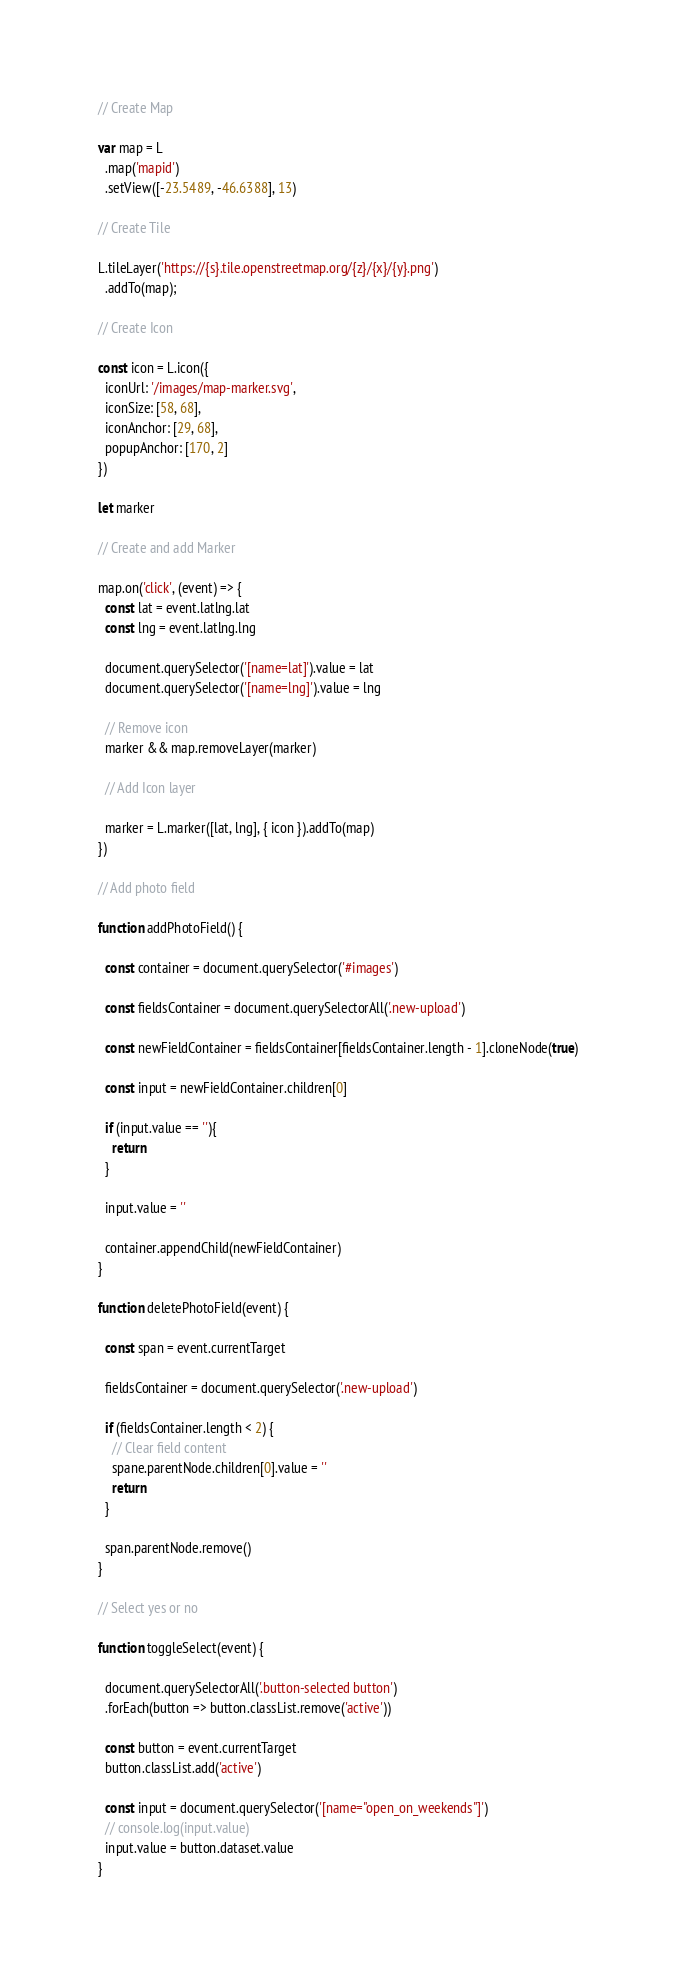Convert code to text. <code><loc_0><loc_0><loc_500><loc_500><_JavaScript_>// Create Map

var map = L
  .map('mapid')
  .setView([-23.5489, -46.6388], 13)

// Create Tile

L.tileLayer('https://{s}.tile.openstreetmap.org/{z}/{x}/{y}.png')
  .addTo(map);

// Create Icon

const icon = L.icon({
  iconUrl: '/images/map-marker.svg',
  iconSize: [58, 68],
  iconAnchor: [29, 68],
  popupAnchor: [170, 2]
})

let marker

// Create and add Marker

map.on('click', (event) => {
  const lat = event.latlng.lat
  const lng = event.latlng.lng

  document.querySelector('[name=lat]').value = lat
  document.querySelector('[name=lng]').value = lng

  // Remove icon
  marker && map.removeLayer(marker)

  // Add Icon layer

  marker = L.marker([lat, lng], { icon }).addTo(map)
})

// Add photo field

function addPhotoField() {

  const container = document.querySelector('#images')
  
  const fieldsContainer = document.querySelectorAll('.new-upload')
  
  const newFieldContainer = fieldsContainer[fieldsContainer.length - 1].cloneNode(true)
  
  const input = newFieldContainer.children[0]
  
  if (input.value == ''){
    return
  }
  
  input.value = ''
  
  container.appendChild(newFieldContainer)
}

function deletePhotoField(event) {
  
  const span = event.currentTarget
  
  fieldsContainer = document.querySelector('.new-upload')
  
  if (fieldsContainer.length < 2) {
    // Clear field content
    spane.parentNode.children[0].value = ''
    return
  }
  
  span.parentNode.remove()
}

// Select yes or no 

function toggleSelect(event) {
  
  document.querySelectorAll('.button-selected button')
  .forEach(button => button.classList.remove('active'))
  
  const button = event.currentTarget
  button.classList.add('active')
  
  const input = document.querySelector('[name="open_on_weekends"]')
  // console.log(input.value)
  input.value = button.dataset.value
}</code> 